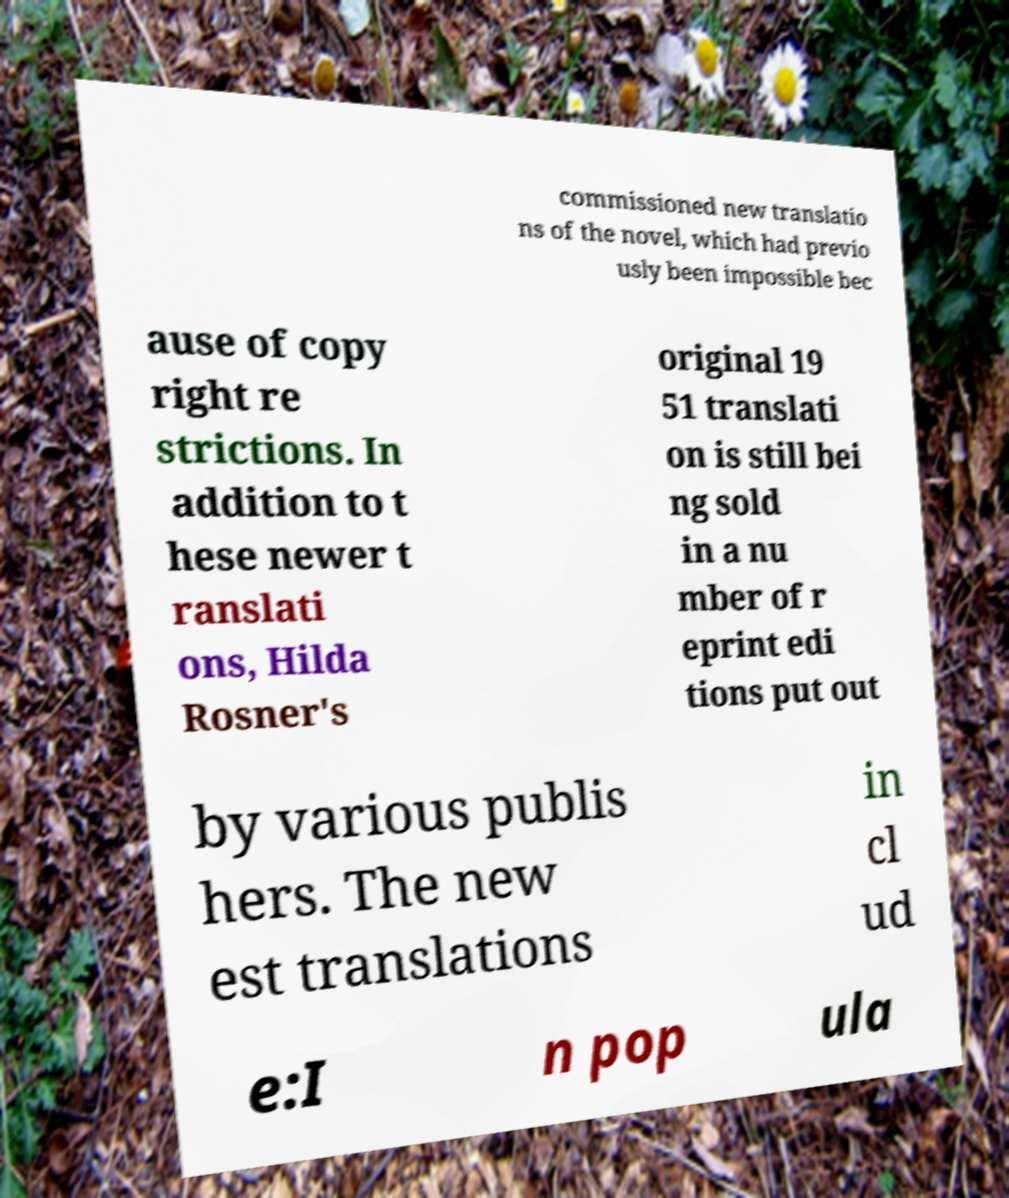What messages or text are displayed in this image? I need them in a readable, typed format. commissioned new translatio ns of the novel, which had previo usly been impossible bec ause of copy right re strictions. In addition to t hese newer t ranslati ons, Hilda Rosner's original 19 51 translati on is still bei ng sold in a nu mber of r eprint edi tions put out by various publis hers. The new est translations in cl ud e:I n pop ula 